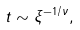<formula> <loc_0><loc_0><loc_500><loc_500>t \sim \xi ^ { - 1 / \nu } ,</formula> 